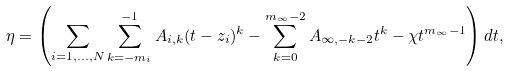Convert formula to latex. <formula><loc_0><loc_0><loc_500><loc_500>\eta = \left ( \sum _ { i = 1 , \dots , N } \sum _ { k = - m _ { i } } ^ { - 1 } A _ { i , k } ( t - z _ { i } ) ^ { k } - \sum _ { k = 0 } ^ { m _ { \infty } - 2 } A _ { \infty , - k - 2 } t ^ { k } - \chi t ^ { m _ { \infty } - 1 } \right ) d t ,</formula> 